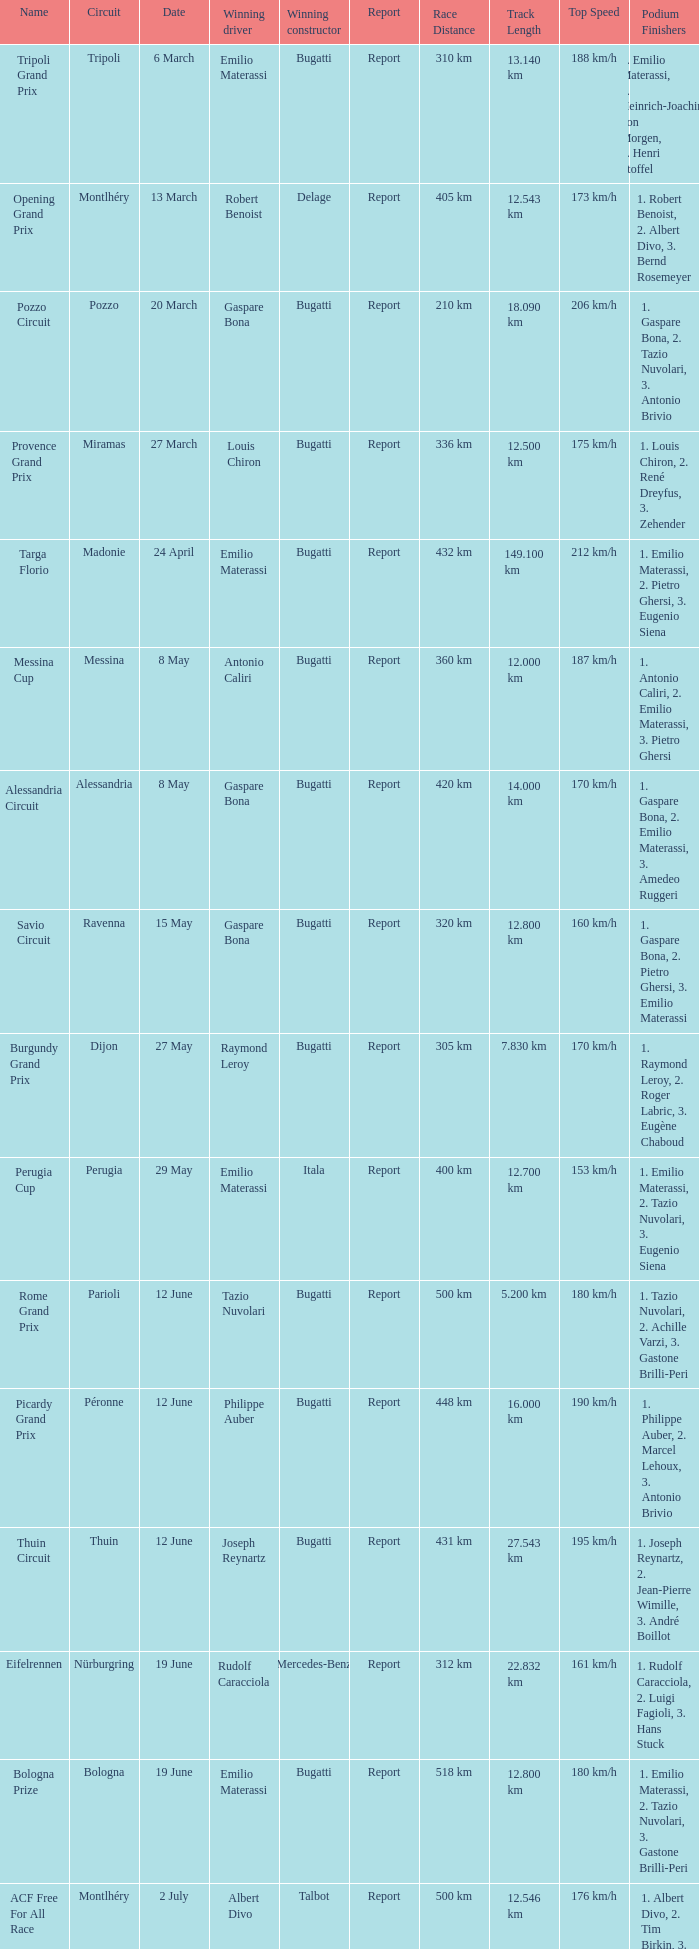Give me the full table as a dictionary. {'header': ['Name', 'Circuit', 'Date', 'Winning driver', 'Winning constructor', 'Report', 'Race Distance', 'Track Length', 'Top Speed', 'Podium Finishers'], 'rows': [['Tripoli Grand Prix', 'Tripoli', '6 March', 'Emilio Materassi', 'Bugatti', 'Report', '310 km', '13.140 km', '188 km/h', '1. Emilio Materassi, 2. Heinrich-Joachim von Morgen, 3. Henri Stoffel'], ['Opening Grand Prix', 'Montlhéry', '13 March', 'Robert Benoist', 'Delage', 'Report', '405 km', '12.543 km', '173 km/h', '1. Robert Benoist, 2. Albert Divo, 3. Bernd Rosemeyer'], ['Pozzo Circuit', 'Pozzo', '20 March', 'Gaspare Bona', 'Bugatti', 'Report', '210 km', '18.090 km', '206 km/h', '1. Gaspare Bona, 2. Tazio Nuvolari, 3. Antonio Brivio'], ['Provence Grand Prix', 'Miramas', '27 March', 'Louis Chiron', 'Bugatti', 'Report', '336 km', '12.500 km', '175 km/h', '1. Louis Chiron, 2. René Dreyfus, 3. Zehender'], ['Targa Florio', 'Madonie', '24 April', 'Emilio Materassi', 'Bugatti', 'Report', '432 km', '149.100 km', '212 km/h', '1. Emilio Materassi, 2. Pietro Ghersi, 3. Eugenio Siena'], ['Messina Cup', 'Messina', '8 May', 'Antonio Caliri', 'Bugatti', 'Report', '360 km', '12.000 km', '187 km/h', '1. Antonio Caliri, 2. Emilio Materassi, 3. Pietro Ghersi'], ['Alessandria Circuit', 'Alessandria', '8 May', 'Gaspare Bona', 'Bugatti', 'Report', '420 km', '14.000 km', '170 km/h', '1. Gaspare Bona, 2. Emilio Materassi, 3. Amedeo Ruggeri'], ['Savio Circuit', 'Ravenna', '15 May', 'Gaspare Bona', 'Bugatti', 'Report', '320 km', '12.800 km', '160 km/h', '1. Gaspare Bona, 2. Pietro Ghersi, 3. Emilio Materassi'], ['Burgundy Grand Prix', 'Dijon', '27 May', 'Raymond Leroy', 'Bugatti', 'Report', '305 km', '7.830 km', '170 km/h', '1. Raymond Leroy, 2. Roger Labric, 3. Eugène Chaboud'], ['Perugia Cup', 'Perugia', '29 May', 'Emilio Materassi', 'Itala', 'Report', '400 km', '12.700 km', '153 km/h', '1. Emilio Materassi, 2. Tazio Nuvolari, 3. Eugenio Siena'], ['Rome Grand Prix', 'Parioli', '12 June', 'Tazio Nuvolari', 'Bugatti', 'Report', '500 km', '5.200 km', '180 km/h', '1. Tazio Nuvolari, 2. Achille Varzi, 3. Gastone Brilli-Peri'], ['Picardy Grand Prix', 'Péronne', '12 June', 'Philippe Auber', 'Bugatti', 'Report', '448 km', '16.000 km', '190 km/h', '1. Philippe Auber, 2. Marcel Lehoux, 3. Antonio Brivio'], ['Thuin Circuit', 'Thuin', '12 June', 'Joseph Reynartz', 'Bugatti', 'Report', '431 km', '27.543 km', '195 km/h', '1. Joseph Reynartz, 2. Jean-Pierre Wimille, 3. André Boillot'], ['Eifelrennen', 'Nürburgring', '19 June', 'Rudolf Caracciola', 'Mercedes-Benz', 'Report', '312 km', '22.832 km', '161 km/h', '1. Rudolf Caracciola, 2. Luigi Fagioli, 3. Hans Stuck'], ['Bologna Prize', 'Bologna', '19 June', 'Emilio Materassi', 'Bugatti', 'Report', '518 km', '12.800 km', '180 km/h', '1. Emilio Materassi, 2. Tazio Nuvolari, 3. Gastone Brilli-Peri'], ['ACF Free For All Race', 'Montlhéry', '2 July', 'Albert Divo', 'Talbot', 'Report', '500 km', '12.546 km', '176 km/h', '1. Albert Divo, 2. Tim Birkin, 3. Louis Chiron'], ['Sporting Commission Cup', 'Montlhéry', '2 July', 'André Boillot', 'Peugeot', 'Report', '500 km', '12.546 km', '160 km/h', '1. André Boillot, 2. Robert Benoist, 3. Raymond Sommer'], ['Grand Prix de la Marne', 'Reims-Gueux', '10 July', 'Philippe Étancelin', 'Bugatti', 'Report', '553 km', '7.816 km', '216 km/h', '1. Philippe Étancelin, 2. Marcel Lehoux, 3. Luigi Fagioli'], ['San Sebastián Grand Prix', 'Lasarte', '25 July', 'Emilio Materassi', 'Bugatti', 'Report', '338 km', '17.260 km', '180 km/h', '1. Emilio Materassi, 2. Tazio Nuvolari, 3. Ernesto Maserati'], ['Coppa Acerbo', 'Pescara', '6 August', 'Giuseppe Campari', 'Alfa Romeo', 'Report', '497 km', '25.800 km', '222 km/h', '1. Giuseppe Campari, 2. Tazio Nuvolari, 3. Achille Varzi'], ['Grand Prix du Comminges', 'Saint-Gaudens', '7 August', 'François Eysermann', 'Bugatti', 'Report', '238 km', '7.140 km', '162 km/h', '1. François Eysermann, 2. Marcel Mongin, 3. "Raph"'], ['Coppa Montenero', 'Montenero', '14 August', 'Emilio Materassi', 'Bugatti', 'Report', '267 km', '22.290 km', '186 km/h', '1. Emilio Materassi, 2. Tazio Nuvolari, 3. Gastone Brilli-Peri'], ['La Baule Grand Prix', 'La Baule', '25 August', 'George Eyston', 'Bugatti', 'Report', '415 km', '12.750 km', '115 km/h', '1. George Eyston, 2. Robert Benoist, 3. René Dreyfus'], ['Milan Grand Prix', 'Monza', '4 September', 'Pietro Bordino', 'Fiat', 'Report', '500 km', '5.750 km', '174 km/h', '1. Pietro Bordino, 2. Emilio Materassi, 3. Tazio Nuvolari'], ['Boulogne Grand Prix', 'Boulogne', '10 September', 'Malcolm Campbell', 'Bugatti', 'Report', '425 km', '13.492 km', '201 km/h', '1. Malcolm Campbell, 2. Marcel Lehoux, 3. Williams'], ['Solituderennen', 'Solitude', '18 September', 'August Momberger', 'Bugatti', 'Report', '230 km', '10.130 km', '158 km/h', '1. August Momberger, 2. Hans Stuck, 3. Gyula Wéber'], ['Thuin Circuit', 'Thuin', '18 September', 'Freddy Charlier', 'Bugatti', 'Report', '479 km', '29.543 km', '190 km/h', '1. Freddy Charlier, 2. Philippe Auber, 3. Eugène Chaboud'], ['Garda Circuit', 'Salò', '9 October', 'Tazio Nuvolari', 'Bugatti', 'Report', '312 km', '10.000 km', '175 km/h', '1. Tazio Nuvolari, 2. Emilio Materassi, 3. Gastone Brilli-Peri'], ['Junior Car Club 200mile race', 'Brooklands', '15 October', 'Malcolm Campbell', 'Bugatti', 'Report', '321 km', '4.217 km', '166 km/h', '1. Malcolm Campbell, 2. Tim Birkin, 3. George Duller'], ['Grand Prix du Salon', 'Montlhéry', '16 October', 'Michel Doré', 'La Licorne', 'Report', '200 km', '12.546 km', '150 km/h', '1. Michel Doré, 2. "Morel", 3. Auguste Eluard'], ['Apuano Circuit', 'Carrara', '28 October', '"Niccoli"', 'Bugatti', 'Report', '72 km', '18.000 km', '160 km/h', '1. "Niccoli", 2. Aldo Benedetti, 3. Emilio Materassi']]} Who was the winning constructor at the circuit of parioli? Bugatti. 